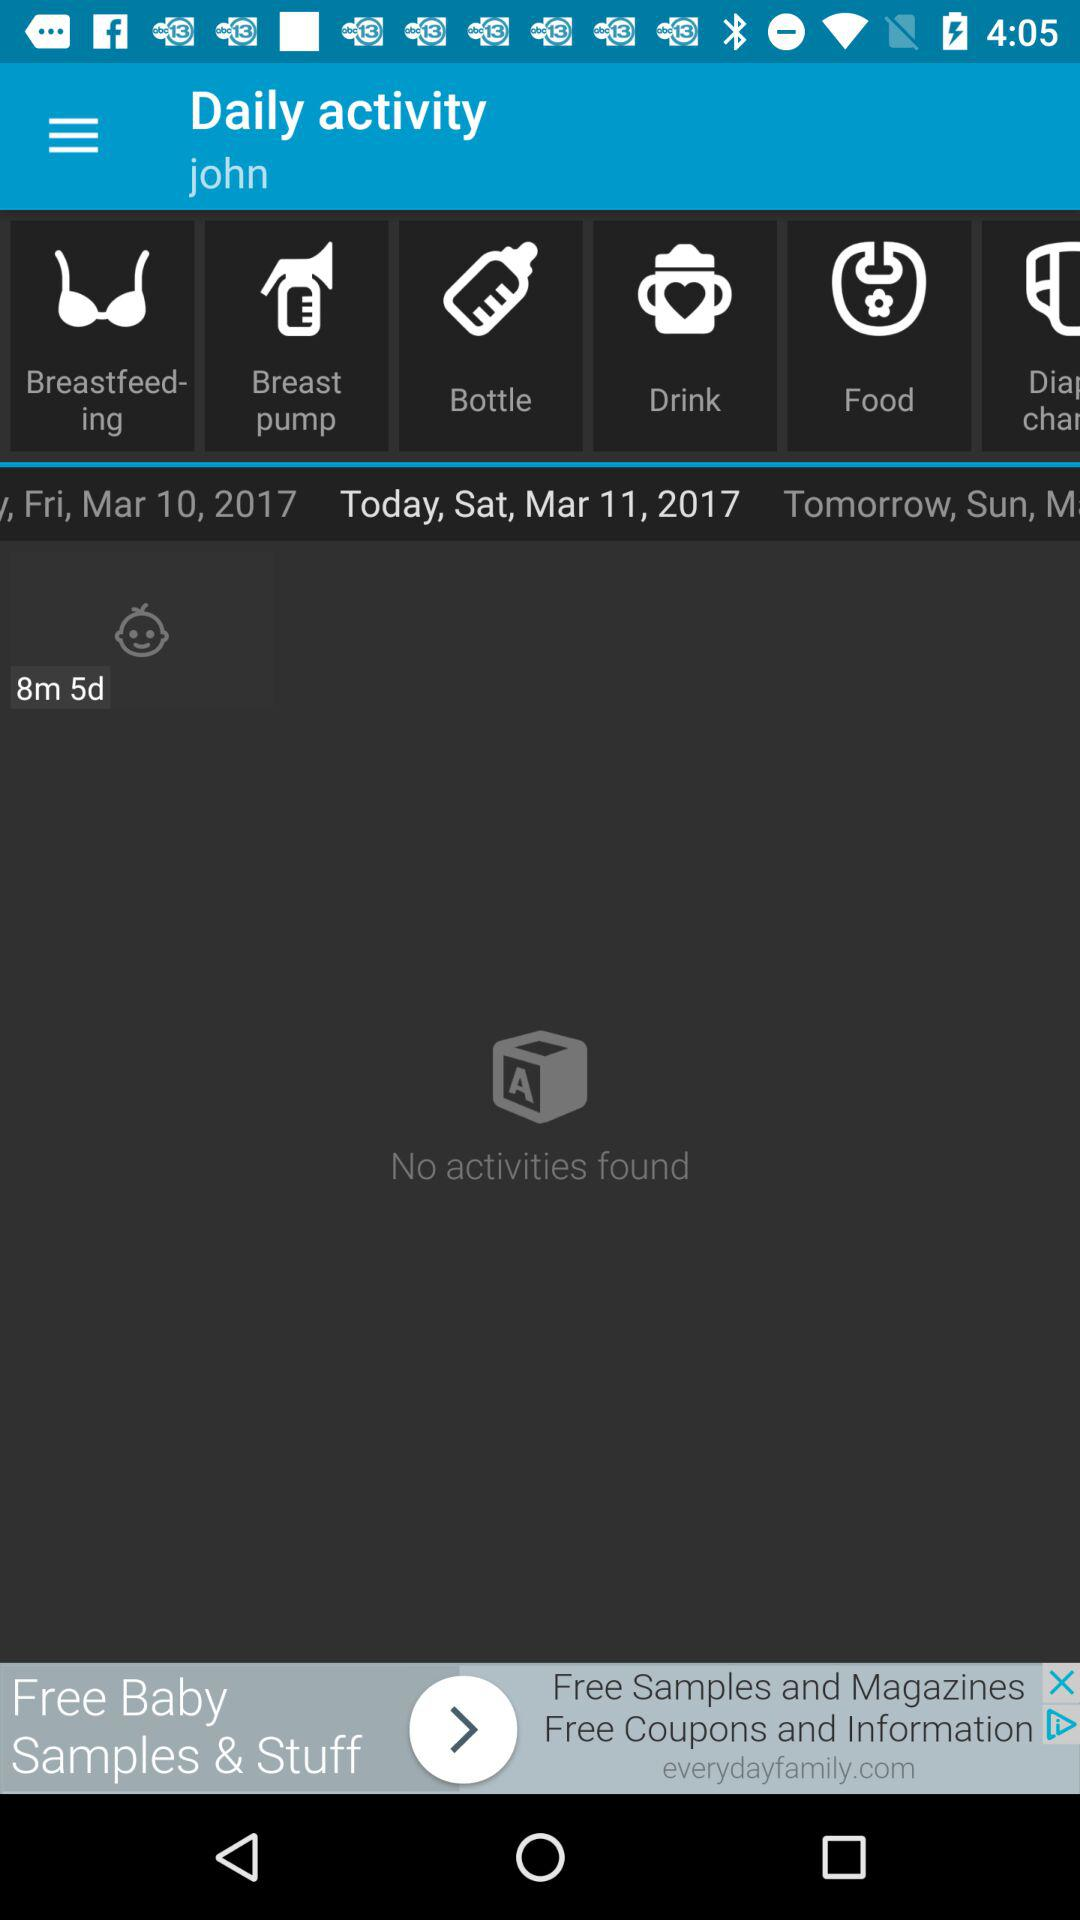How many items are in "Drink"?
When the provided information is insufficient, respond with <no answer>. <no answer> 